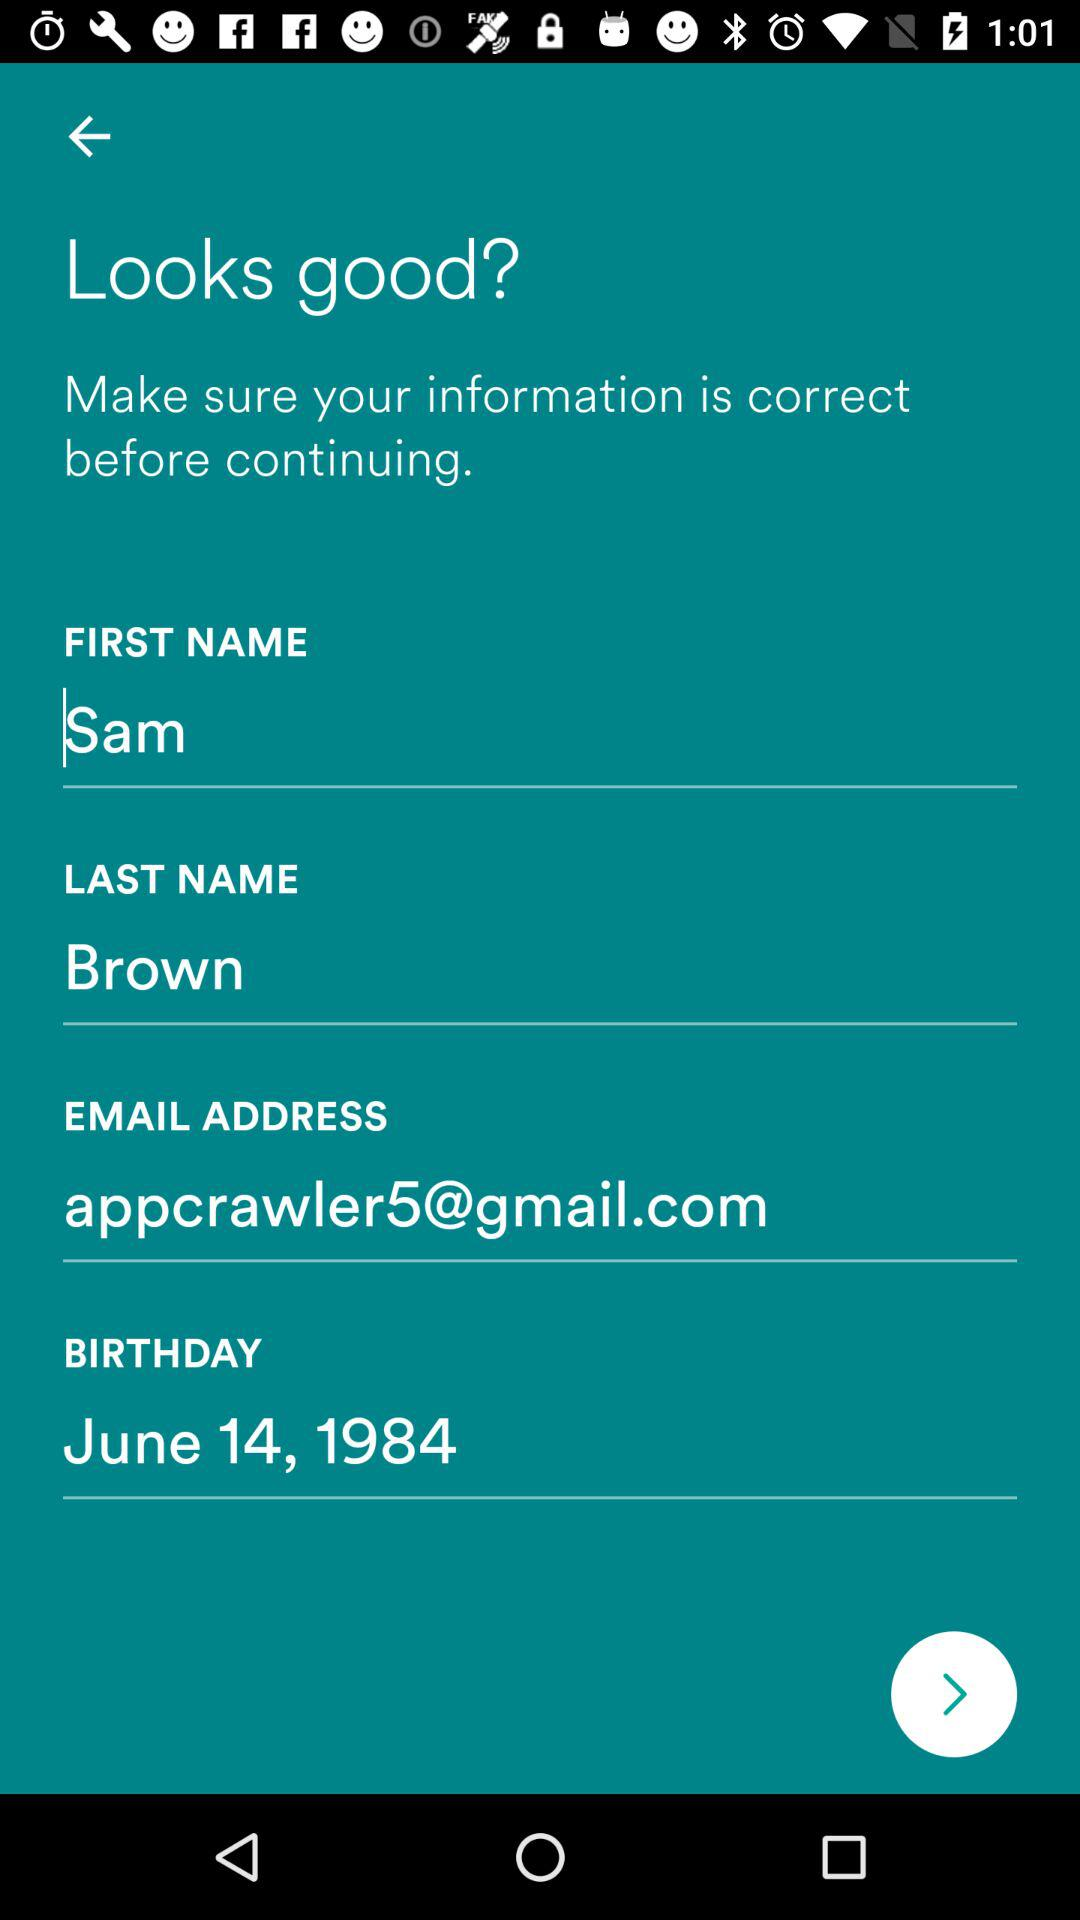What is the user's name? The user's name is Sam Brown. 